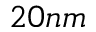<formula> <loc_0><loc_0><loc_500><loc_500>2 0 n m</formula> 